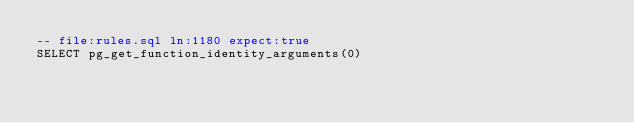Convert code to text. <code><loc_0><loc_0><loc_500><loc_500><_SQL_>-- file:rules.sql ln:1180 expect:true
SELECT pg_get_function_identity_arguments(0)
</code> 